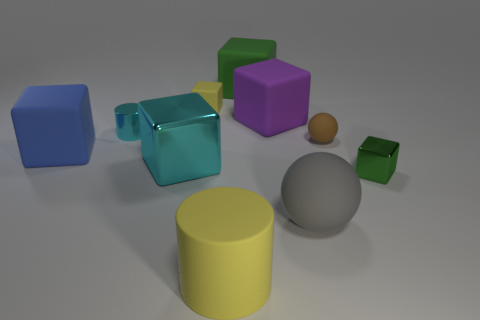Subtract all tiny rubber blocks. How many blocks are left? 5 Subtract all cylinders. How many objects are left? 8 Subtract 1 cubes. How many cubes are left? 5 Subtract all green cylinders. How many green cubes are left? 2 Subtract all brown balls. Subtract all green cylinders. How many balls are left? 1 Subtract all big blue objects. Subtract all purple matte objects. How many objects are left? 8 Add 4 metal objects. How many metal objects are left? 7 Add 9 yellow cubes. How many yellow cubes exist? 10 Subtract all gray spheres. How many spheres are left? 1 Subtract 0 green cylinders. How many objects are left? 10 